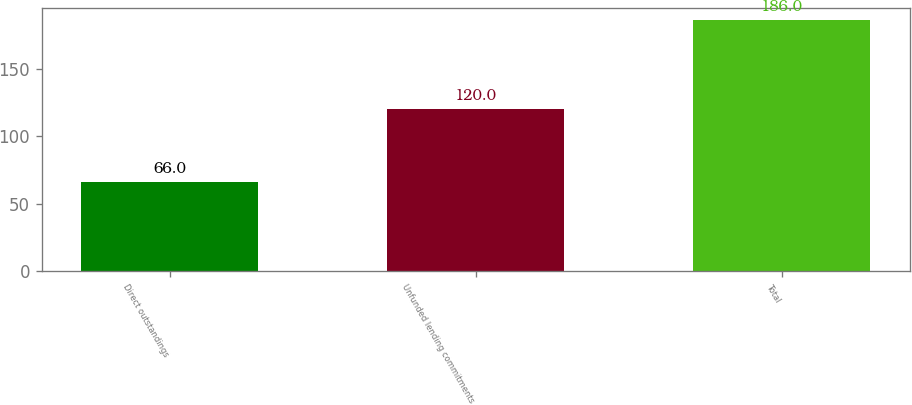Convert chart. <chart><loc_0><loc_0><loc_500><loc_500><bar_chart><fcel>Direct outstandings<fcel>Unfunded lending commitments<fcel>Total<nl><fcel>66<fcel>120<fcel>186<nl></chart> 